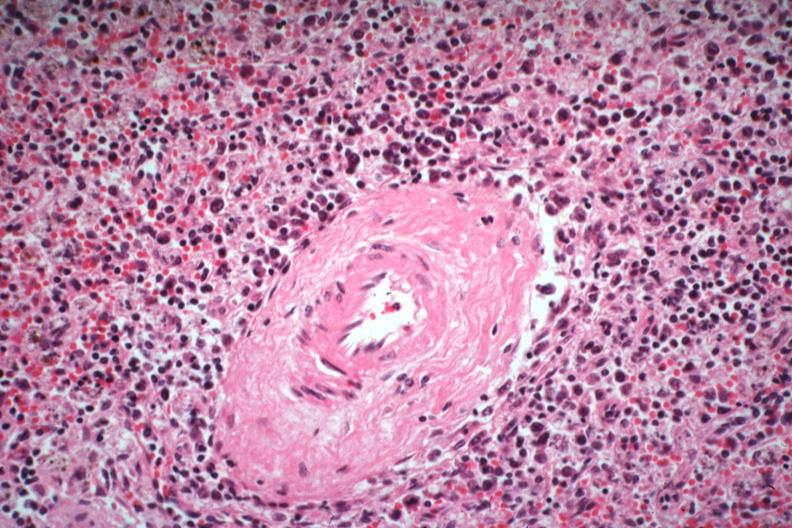what is present?
Answer the question using a single word or phrase. Spleen 